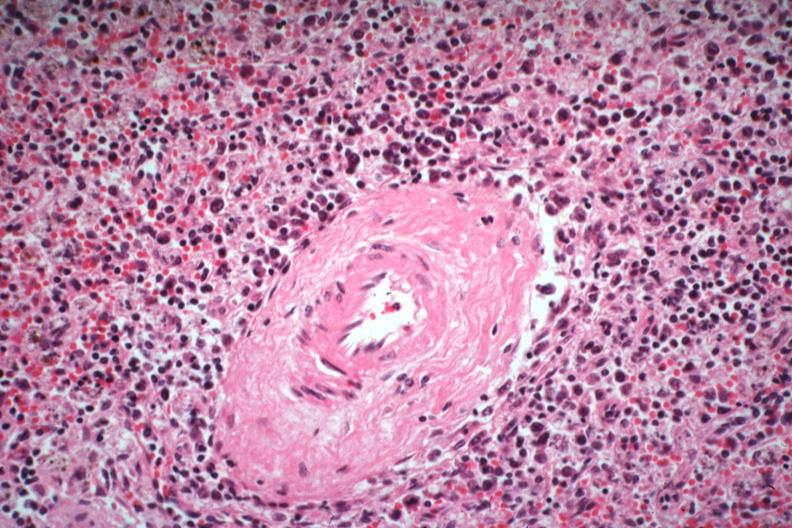what is present?
Answer the question using a single word or phrase. Spleen 